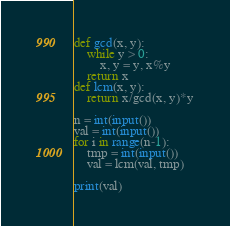<code> <loc_0><loc_0><loc_500><loc_500><_Python_>def gcd(x, y):
    while y > 0:
        x, y = y, x%y
    return x
def lcm(x, y):
    return x/gcd(x, y)*y

n = int(input())
val = int(input())
for i in range(n-1):
    tmp = int(input())
    val = lcm(val, tmp)

print(val)</code> 